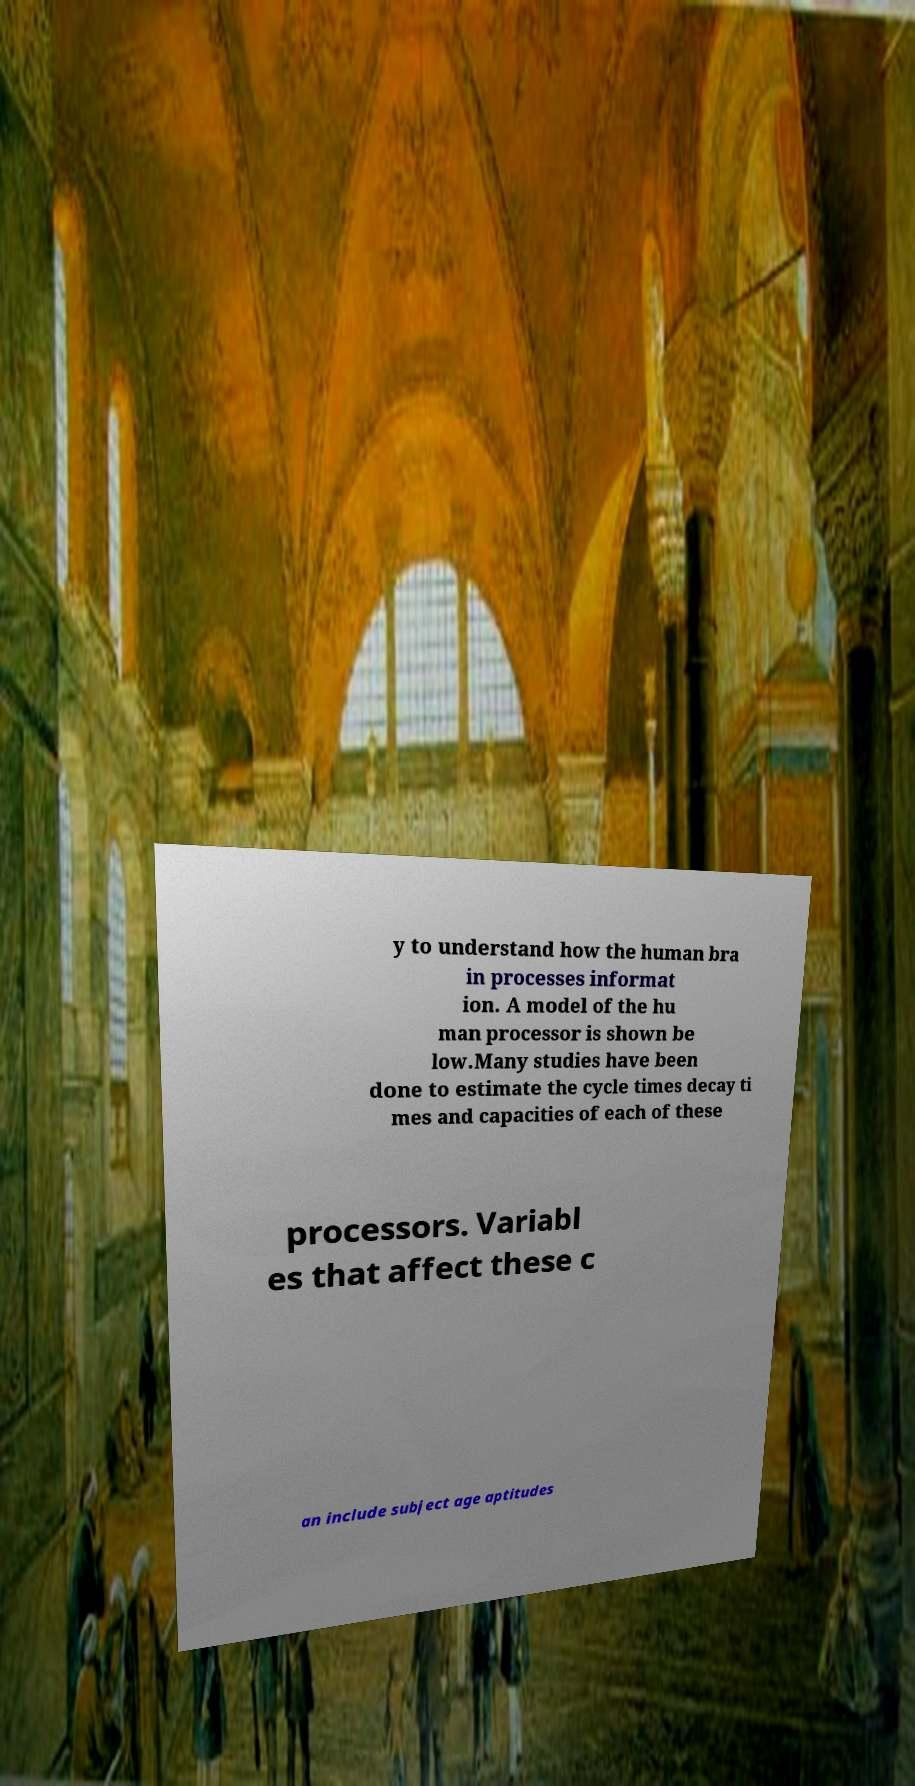Please read and relay the text visible in this image. What does it say? y to understand how the human bra in processes informat ion. A model of the hu man processor is shown be low.Many studies have been done to estimate the cycle times decay ti mes and capacities of each of these processors. Variabl es that affect these c an include subject age aptitudes 